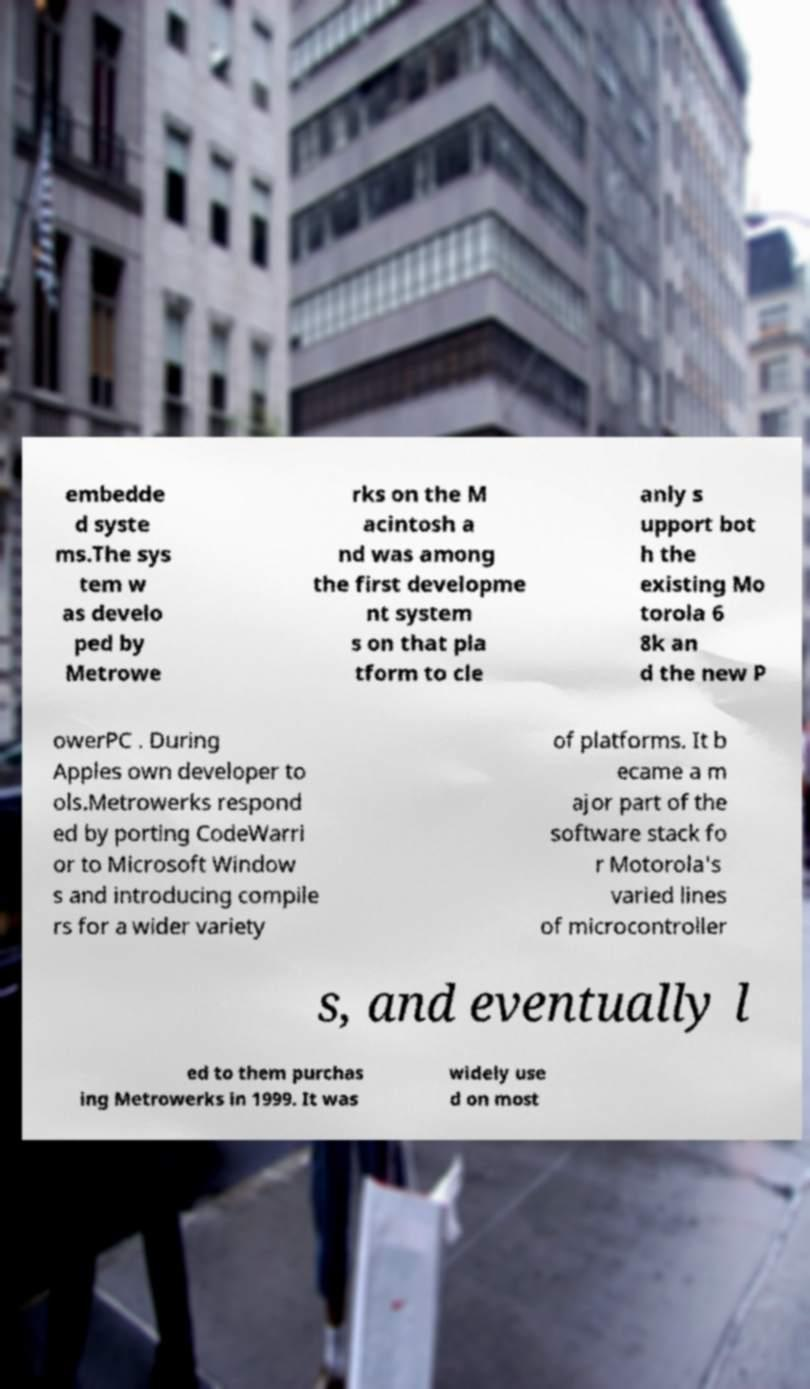For documentation purposes, I need the text within this image transcribed. Could you provide that? embedde d syste ms.The sys tem w as develo ped by Metrowe rks on the M acintosh a nd was among the first developme nt system s on that pla tform to cle anly s upport bot h the existing Mo torola 6 8k an d the new P owerPC . During Apples own developer to ols.Metrowerks respond ed by porting CodeWarri or to Microsoft Window s and introducing compile rs for a wider variety of platforms. It b ecame a m ajor part of the software stack fo r Motorola's varied lines of microcontroller s, and eventually l ed to them purchas ing Metrowerks in 1999. It was widely use d on most 